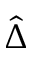Convert formula to latex. <formula><loc_0><loc_0><loc_500><loc_500>\hat { \Delta }</formula> 